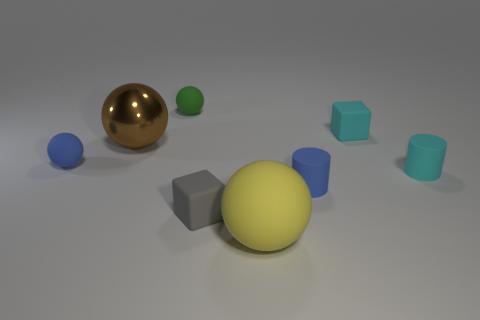Are there the same number of small cyan rubber cubes that are in front of the gray cube and small matte things that are on the left side of the green sphere?
Your answer should be compact. No. How many cyan cylinders are to the left of the small cube that is right of the tiny blue rubber thing to the right of the large metallic object?
Offer a terse response. 0. There is a large metal object; does it have the same color as the thing in front of the small gray matte cube?
Ensure brevity in your answer.  No. Are there more small blue matte things to the left of the gray rubber block than tiny purple rubber spheres?
Your answer should be very brief. Yes. What number of things are either blue objects that are right of the large yellow ball or small rubber things right of the large rubber sphere?
Your answer should be compact. 3. There is a yellow object that is the same material as the small cyan block; what is its size?
Your answer should be compact. Large. There is a small blue thing right of the gray matte thing; is its shape the same as the metal object?
Offer a terse response. No. What number of brown objects are either small things or metal spheres?
Offer a terse response. 1. How many other objects are the same shape as the big brown metallic thing?
Your answer should be very brief. 3. What is the shape of the thing that is in front of the metallic thing and on the left side of the green matte ball?
Give a very brief answer. Sphere. 